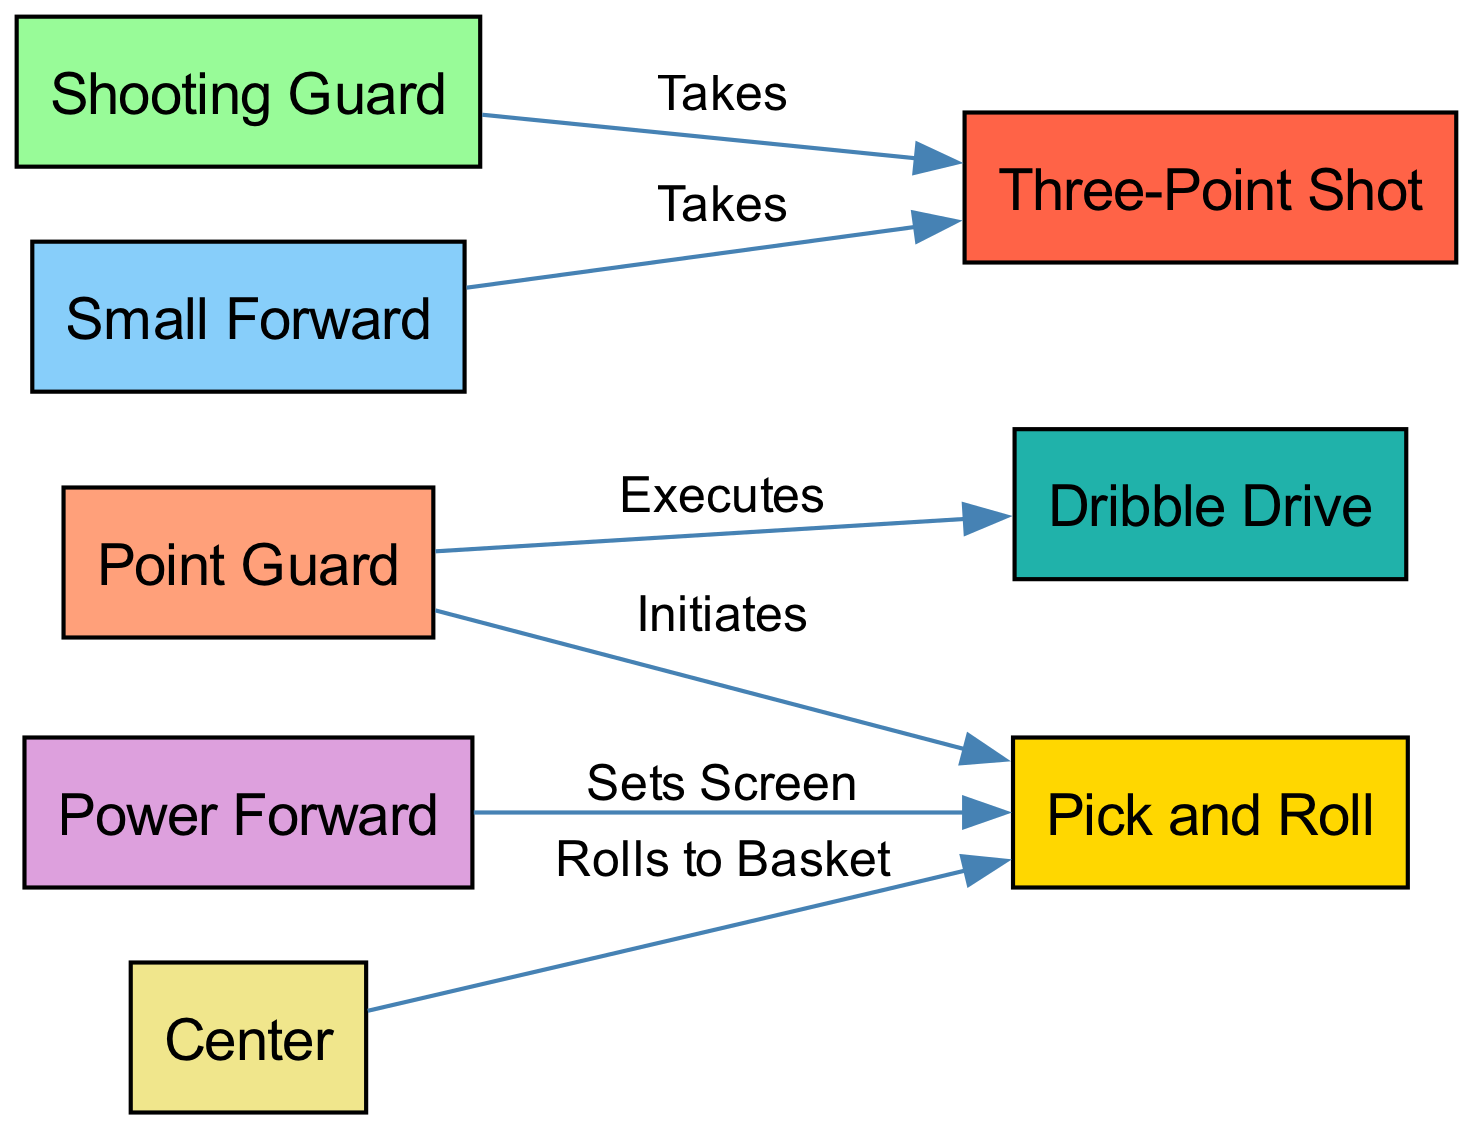What is the total number of nodes in the diagram? The diagram contains nodes representing different players and play strategies: Point Guard, Shooting Guard, Small Forward, Power Forward, Center, Pick and Roll, Three-Point Shot, and Dribble Drive, adding up to a total of eight nodes.
Answer: 8 Who is responsible for initiating the Pick and Roll? The Point Guard is indicated to be the player that initiates the Pick and Roll in the diagram.
Answer: Point Guard Which player takes the Three-Point Shot according to the diagram? Both the Shooting Guard and Small Forward are shown to take the Three-Point Shot as indicated by the edges leading from these nodes to the Three-Point Shot node.
Answer: Shooting Guard, Small Forward What action does the Power Forward perform with regard to the Pick and Roll? The diagram specifies that the Power Forward sets a screen for the Pick and Roll, as shown by the edge connecting the Power Forward to the Pick and Roll node.
Answer: Sets Screen How many passing options are there from the Point Guard? The Point Guard has two passing options: one to the Pick and Roll and the other to the Dribble Drive, indicating a total of two possible actions available from this player.
Answer: 2 Which player rolls to the basket during the Pick and Roll? The Center is the player that rolls to the basket as per the connection from the Center node to the Pick and Roll node in the diagram.
Answer: Center What interaction exists between the Shooting Guard and the Three-Point Shot? The Shooting Guard directly takes the Three-Point Shot, which is shown through the directed edge connecting these two nodes in the diagram.
Answer: Takes Which two players are shown to take a Three-Point Shot? The diagram indicates that both the Shooting Guard and the Small Forward take the Three-Point Shot, as represented by edges from both players to the Three-Point Shot node.
Answer: Shooting Guard, Small Forward What does the Dribble Drive action represent in relation to the Point Guard? The Dribble Drive action is executed by the Point Guard, as indicated by the directed connection from the Point Guard to the Dribble Drive node within the diagram.
Answer: Executes 